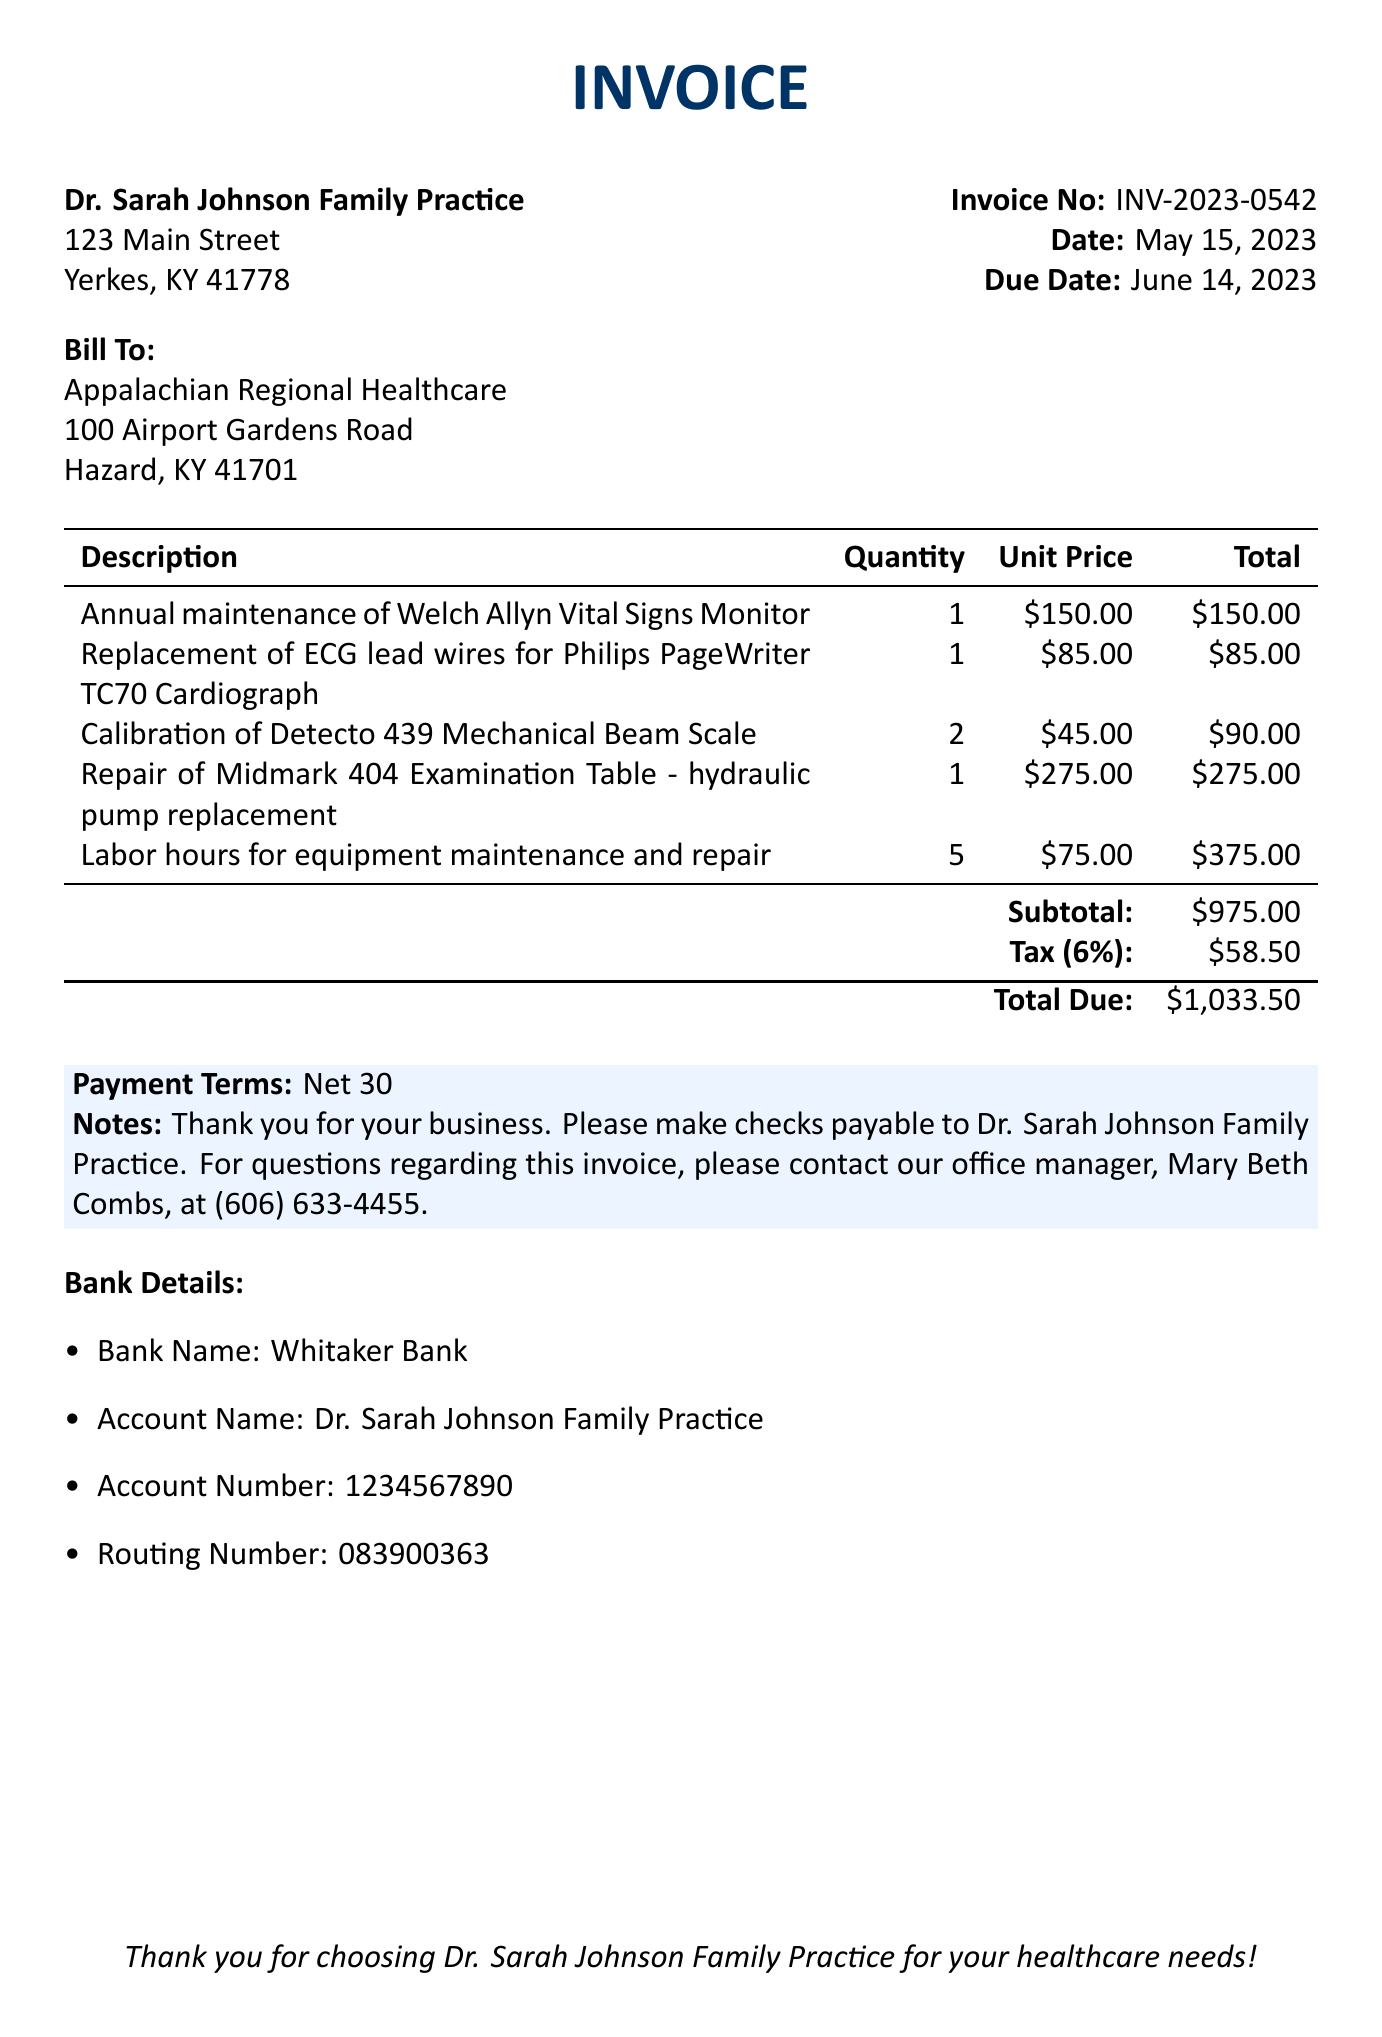What is the invoice number? The invoice number is explicitly mentioned in the document, which is used for tracking purposes.
Answer: INV-2023-0542 What is the due date for the invoice? The due date is specified in the document, indicating when payment should be made.
Answer: June 14, 2023 Who is the customer? The customer name is stated in the document and is the entity being billed.
Answer: Appalachian Regional Healthcare What is the subtotal amount? The subtotal is calculated before tax and is a key part of the financial summary on the invoice.
Answer: $975.00 How many labor hours are charged? The document lists the quantity of labor hours involved in the maintenance and repair services.
Answer: 5 What is the tax rate applied? The tax rate is stated in the document and affects the total amount due.
Answer: 6% What is the total amount due? The total due is the final amount that needs to be paid, inclusive of the subtotal and tax.
Answer: $1,033.50 What payment terms are specified? Payment terms detail when the payment is expected and can indicate late fees if applicable.
Answer: Net 30 What is included in the notes? The notes section often contains additional information or thanks to the customer for their business.
Answer: Thank you for your business. Please make checks payable to Dr. Sarah Johnson Family Practice. For questions regarding this invoice, please contact our office manager, Mary Beth Combs, at (606) 633-4455 